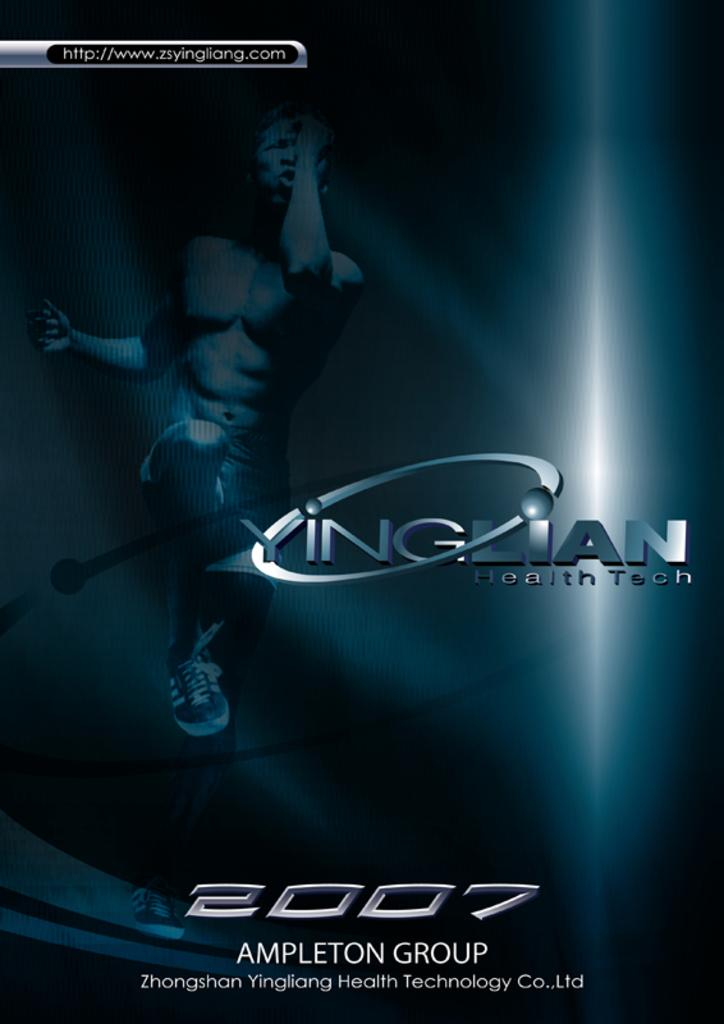<image>
Offer a succinct explanation of the picture presented. A poster from Zhongshan Yingliang Health Technology whose website can be found at http://www.zsyingliang.com. 